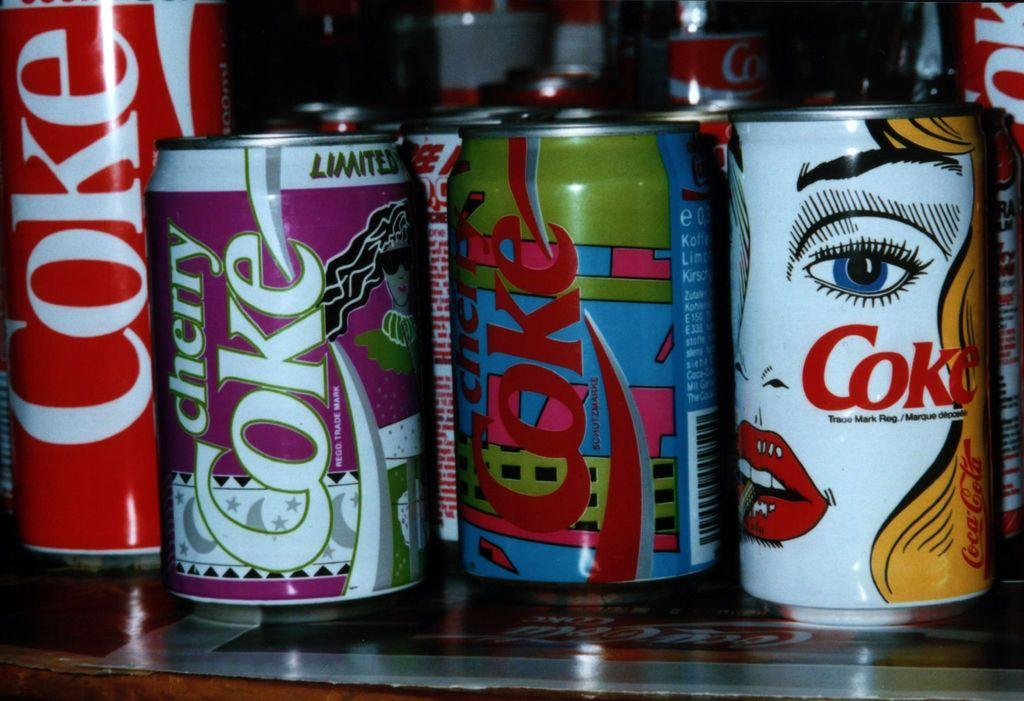Provide a one-sentence caption for the provided image. a collection of COKE soda cans that are artistic. 